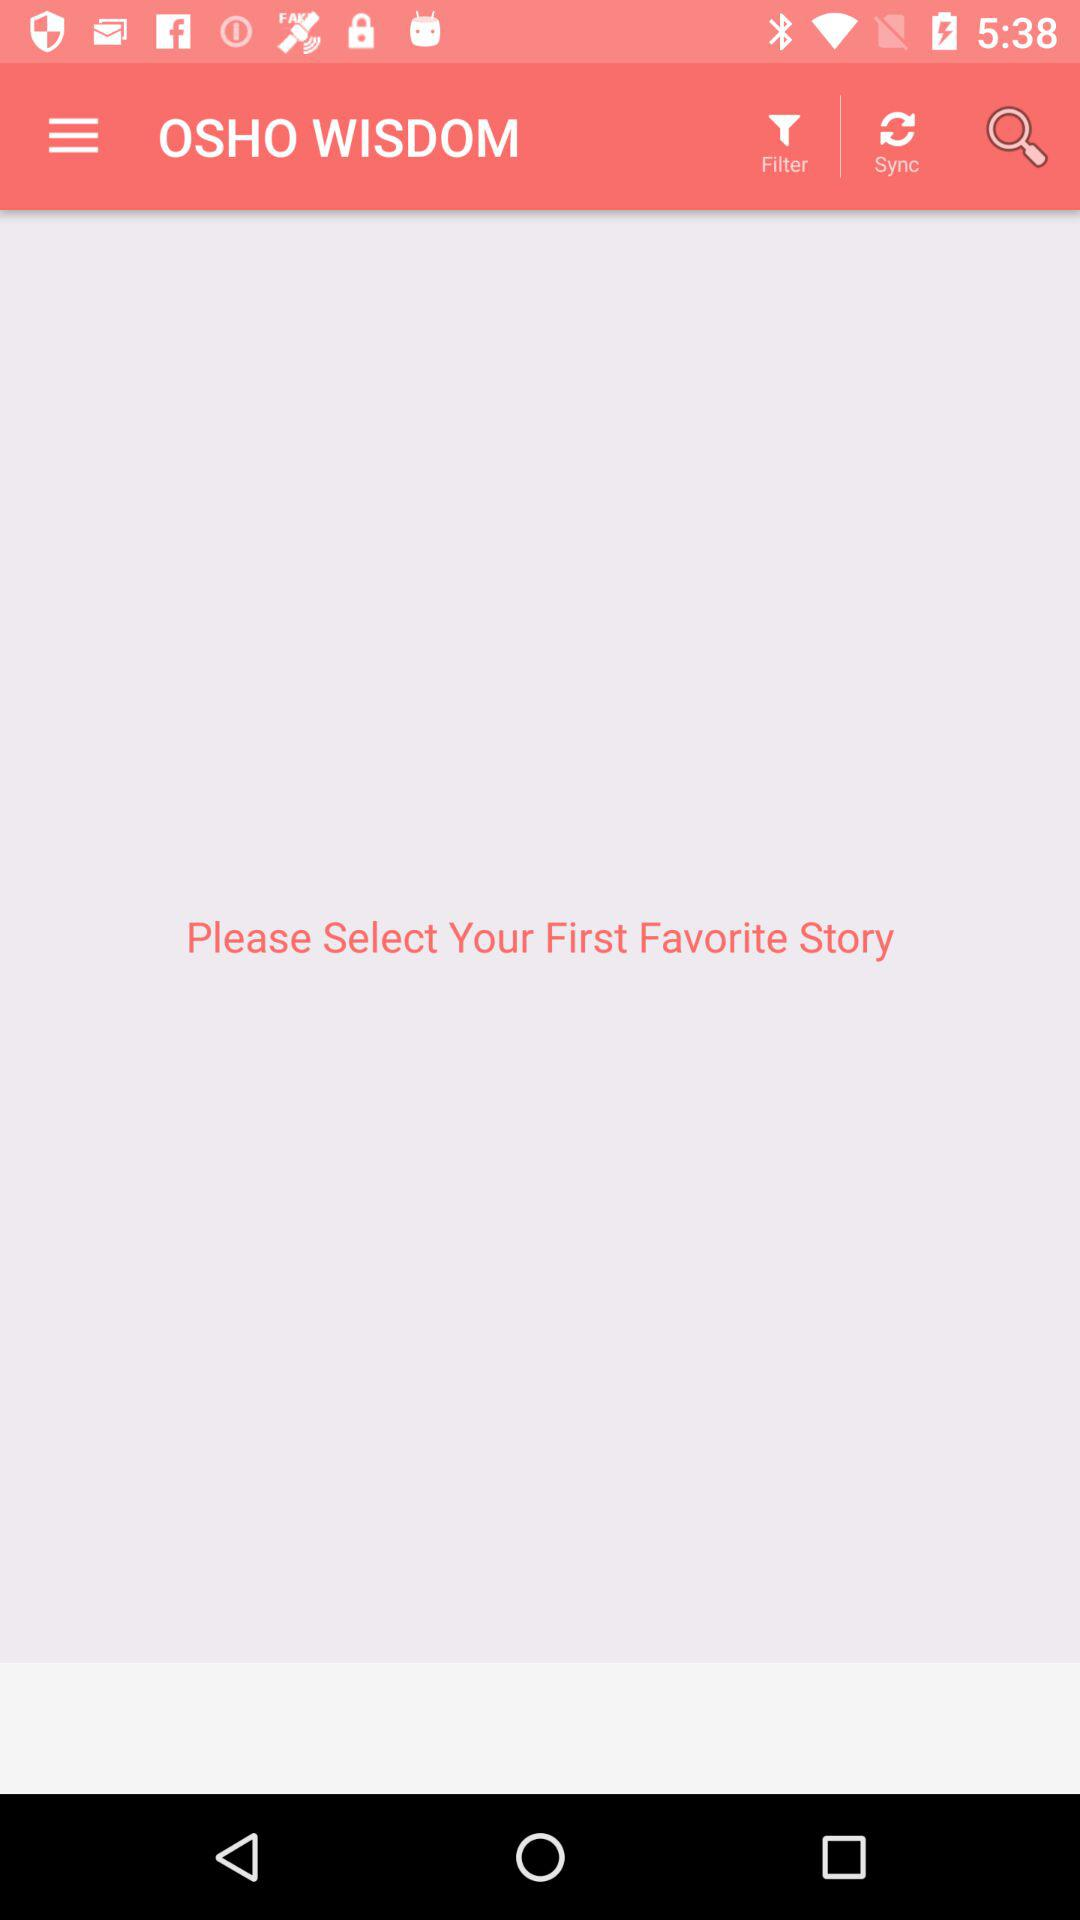When was the last time the application was synced?
When the provided information is insufficient, respond with <no answer>. <no answer> 